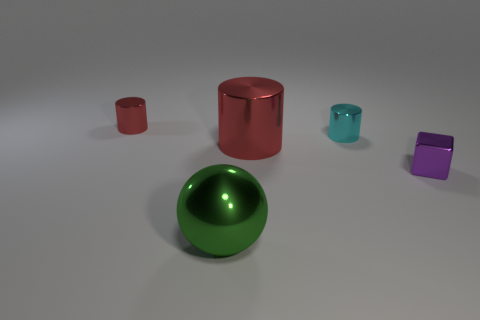Is there another small metal thing that has the same shape as the tiny red object?
Give a very brief answer. Yes. What is the shape of the cyan metal thing that is the same size as the purple block?
Ensure brevity in your answer.  Cylinder. There is a tiny metallic cylinder that is in front of the red thing behind the small cyan shiny cylinder; are there any small cubes on the right side of it?
Your response must be concise. Yes. Is there a cyan cylinder of the same size as the purple shiny thing?
Provide a succinct answer. Yes. There is a shiny object that is in front of the tiny purple thing; how big is it?
Make the answer very short. Large. There is a small shiny cylinder that is to the left of the large thing that is left of the red thing to the right of the large green thing; what is its color?
Give a very brief answer. Red. There is a tiny object that is in front of the large thing behind the tiny block; what is its color?
Offer a very short reply. Purple. Are there more cylinders in front of the big red metallic cylinder than blocks that are in front of the green thing?
Offer a very short reply. No. Is the material of the tiny red object that is on the left side of the big sphere the same as the big object that is in front of the tiny cube?
Your answer should be very brief. Yes. Are there any small cyan metallic cylinders left of the small cyan cylinder?
Provide a succinct answer. No. 